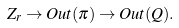Convert formula to latex. <formula><loc_0><loc_0><loc_500><loc_500>Z _ { r } \to O u t ( \pi ) \to O u t ( Q ) .</formula> 